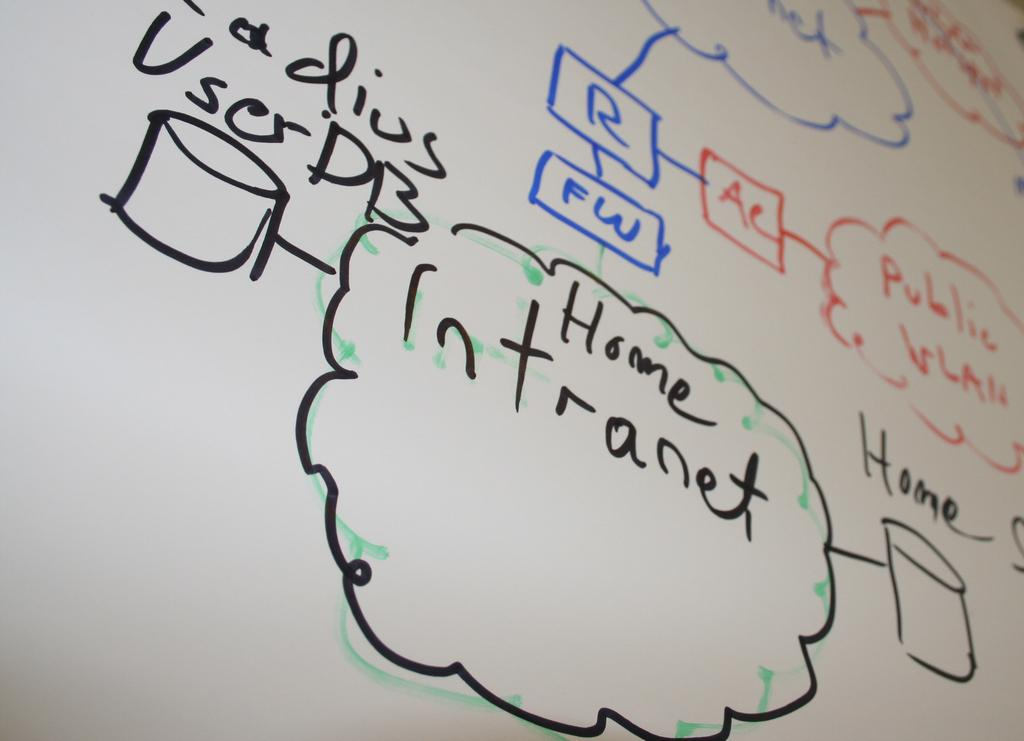<image>
Describe the image concisely. A whiteboard shows diagrams and notations referencing a home Intranet. 